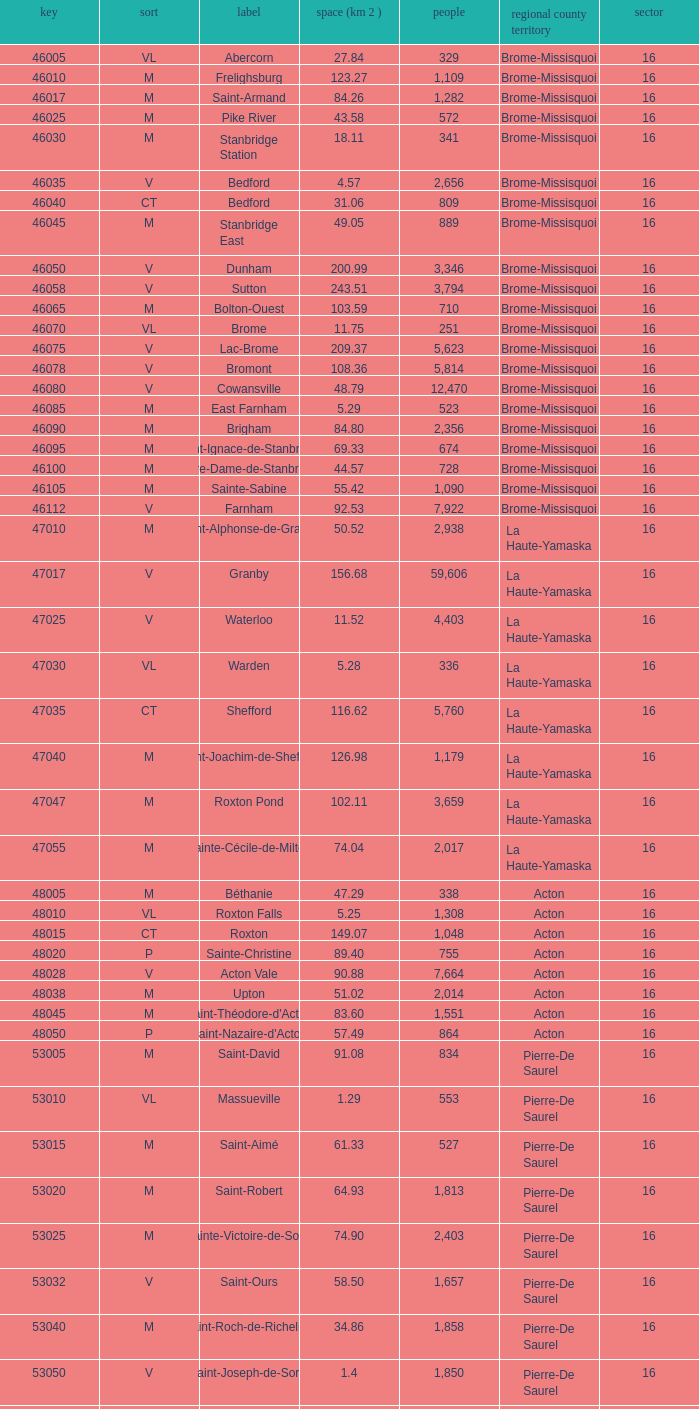What is the code for a Le Haut-Saint-Laurent municipality that has 16 or more regions? None. 